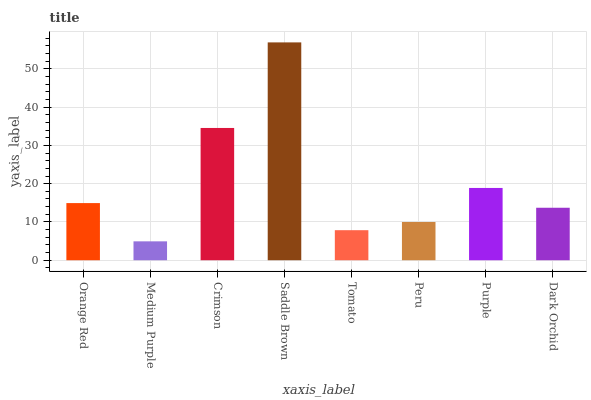Is Crimson the minimum?
Answer yes or no. No. Is Crimson the maximum?
Answer yes or no. No. Is Crimson greater than Medium Purple?
Answer yes or no. Yes. Is Medium Purple less than Crimson?
Answer yes or no. Yes. Is Medium Purple greater than Crimson?
Answer yes or no. No. Is Crimson less than Medium Purple?
Answer yes or no. No. Is Orange Red the high median?
Answer yes or no. Yes. Is Dark Orchid the low median?
Answer yes or no. Yes. Is Peru the high median?
Answer yes or no. No. Is Crimson the low median?
Answer yes or no. No. 